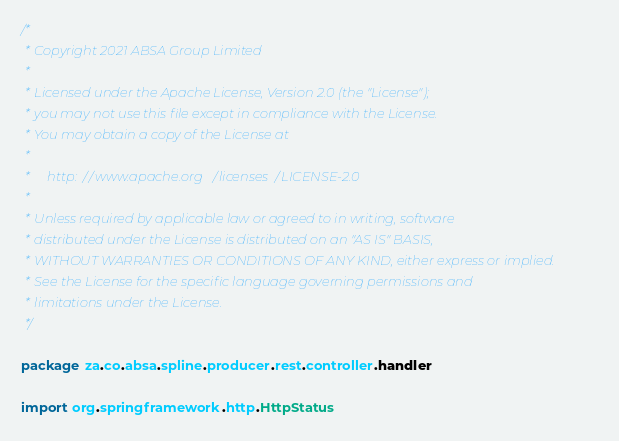<code> <loc_0><loc_0><loc_500><loc_500><_Scala_>/*
 * Copyright 2021 ABSA Group Limited
 *
 * Licensed under the Apache License, Version 2.0 (the "License");
 * you may not use this file except in compliance with the License.
 * You may obtain a copy of the License at
 *
 *     http://www.apache.org/licenses/LICENSE-2.0
 *
 * Unless required by applicable law or agreed to in writing, software
 * distributed under the License is distributed on an "AS IS" BASIS,
 * WITHOUT WARRANTIES OR CONDITIONS OF ANY KIND, either express or implied.
 * See the License for the specific language governing permissions and
 * limitations under the License.
 */

package za.co.absa.spline.producer.rest.controller.handler

import org.springframework.http.HttpStatus</code> 